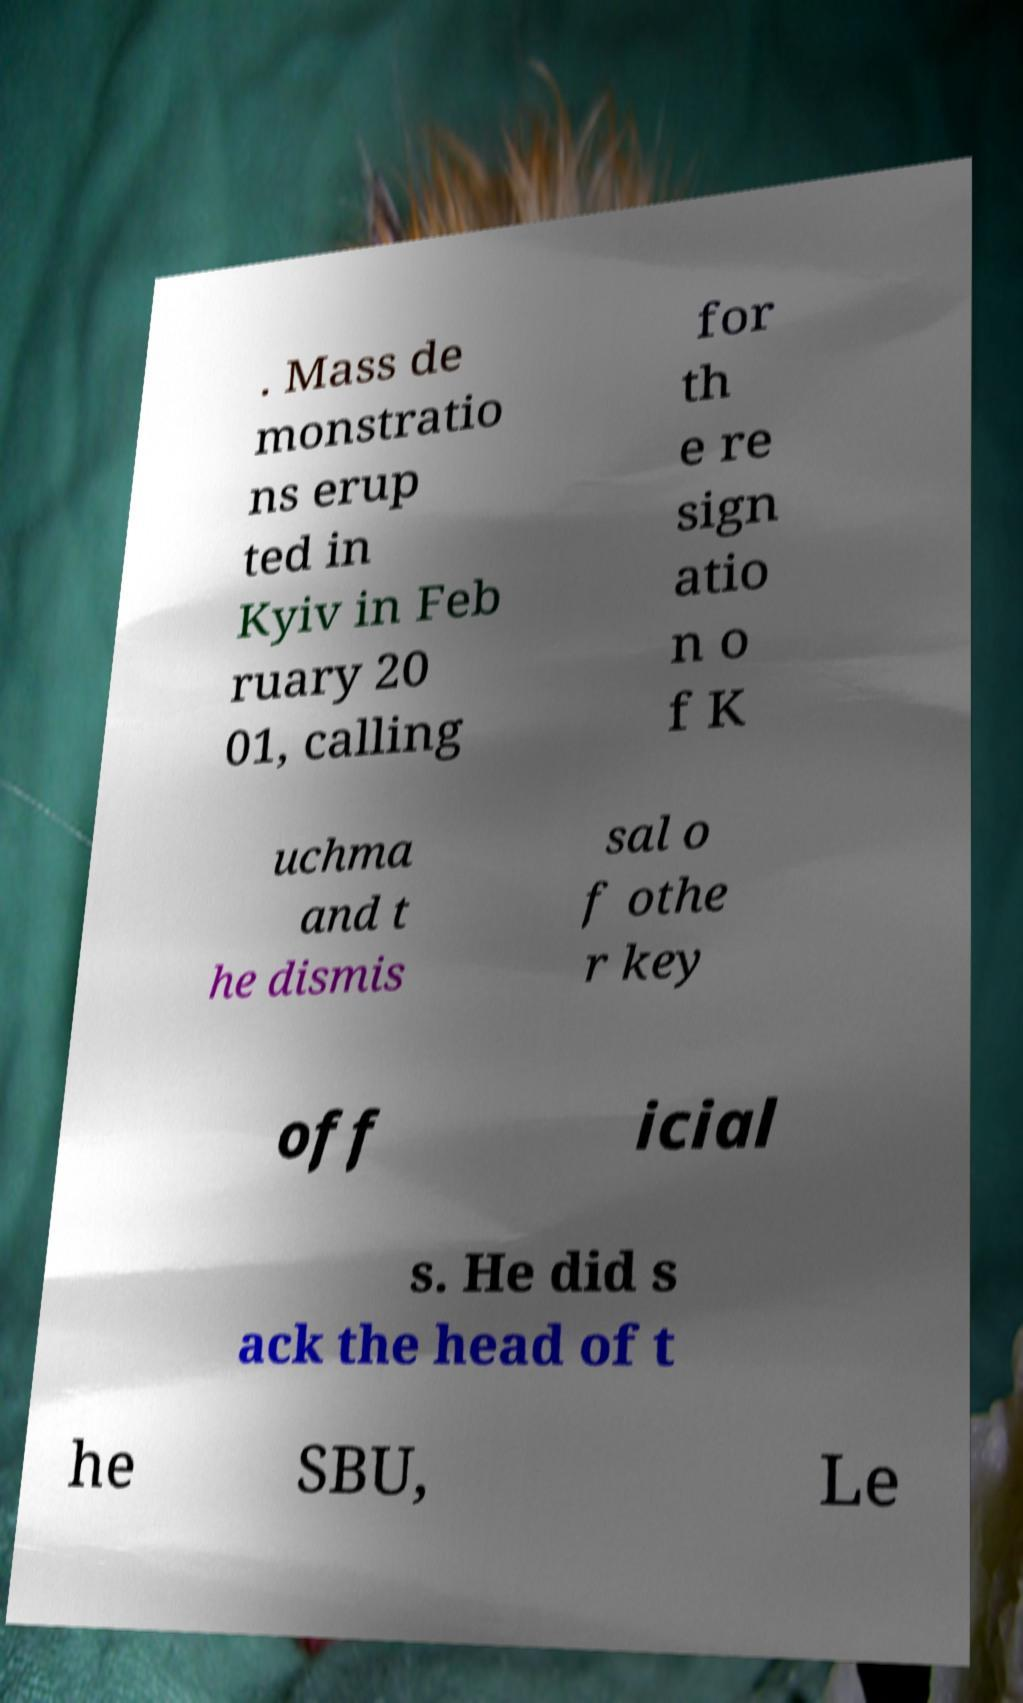Please identify and transcribe the text found in this image. . Mass de monstratio ns erup ted in Kyiv in Feb ruary 20 01, calling for th e re sign atio n o f K uchma and t he dismis sal o f othe r key off icial s. He did s ack the head of t he SBU, Le 